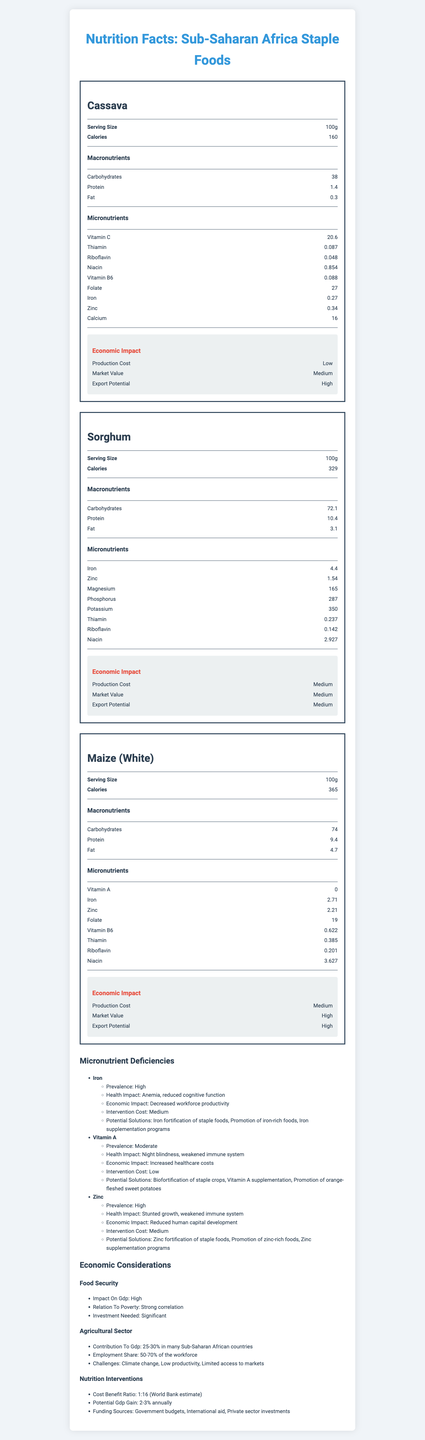what is the serving size for Cassava? The document lists each staple food along with its serving size, and for Cassava, it is specified as "100g".
Answer: 100g how many calories are in 100g of Maize (White)? The document shows the calories for each staple food, and for Maize (White), it is listed as 365 calories per 100g serving.
Answer: 365 what are two potential solutions to zinc deficiency mentioned in the document? Under the micronutrient deficiencies section, the document lists "Zinc fortification of staple foods" and "Promotion of zinc-rich foods" as potential solutions for zinc deficiency.
Answer: Zinc fortification of staple foods, Promotion of zinc-rich foods which staple food has the highest protein content per 100g serving? A. Cassava B. Sorghum C. Maize (White) Sorghum has the highest protein content per 100g serving at 10.4g. Cassava has 1.4g and Maize (White) has 9.4g.
Answer: B is the prevalence of iron deficiency described as low in the document? The document states that the prevalence of iron deficiency is "High".
Answer: No how does vitamin A deficiency economically impact communities according to the document? The document mentions that vitamin A deficiency has an economic impact of "Increased healthcare costs".
Answer: Increased healthcare costs which micronutrient in Sorghum is the highest in content per 100g serving? A. Iron B. Potassium C. Magnesium D. Zinc Sorghum has 350mg of potassium per 100g serving, which is higher than the amounts of iron, magnesium, and zinc.
Answer: B what is the cost-benefit ratio for nutrition interventions mentioned in the document? The document states that the cost-benefit ratio for nutrition interventions is 1:16 according to the World Bank estimate.
Answer: 1:16 which staple food has the highest market value according to the document? The document lists "High" for the market value of Maize (White), whereas Cassava and Sorghum are listed as "Medium".
Answer: Maize (White) what are the potential GDP gains from nutrition interventions as specified in the document? The document states that the potential GDP gains from nutrition interventions are 2-3% annually.
Answer: 2-3% annually describe the main economic challenges faced by the agricultural sector in Sub-Saharan Africa as mentioned in the document. The document lists these challenges under the economic considerations section for the agricultural sector.
Answer: Climate change, Low productivity, Limited access to markets summarize the economic impact of micronutrient deficiencies as described in the document. According to the document, micronutrient deficiencies such as iron, vitamin A, and zinc have diverse economic impacts including reduced workforce productivity, increased healthcare costs, and reduced human capital development.
Answer: Reduced workforce productivity, Increased healthcare costs, Reduced human capital development how many grams of carbohydrates are there in 100g of Sorghum? The document lists the macronutrient content for each staple food, and Sorghum has 72.1g of carbohydrates per 100g serving.
Answer: 72.1g which staple food has the highest calories per serving? Among the listed staple foods, Maize (White) has the highest calories at 365 per 100g.
Answer: Maize (White) what is the role of food security in GDP impact according to the document? The document mentions that food security has a high impact on GDP.
Answer: High what percentage of the workforce does the agricultural sector employ in many Sub-Saharan African countries? The document highlights that the agricultural sector employs 50-70% of the workforce in many Sub-Saharan African countries.
Answer: 50-70% what is the level of calcium content in Cassava per 100g serving? The micronutrient section for Cassava shows that it contains 16mg of calcium per 100g serving.
Answer: 16mg is the production cost for Sorghum considered low in the document? The document lists the production cost for Sorghum as "Medium".
Answer: No what cannot be determined from the document? The document mentions that low productivity is a challenge, but it does not specify detailed interventions to address it.
Answer: Precise interventions for reducing low productivity in the agricultural sector how are the effects of climate change on food security discussed in the document? While the document mentions climate change as a challenge for the agricultural sector, it does not provide detailed insights on its specific effects on food security.
Answer: Not enough information 